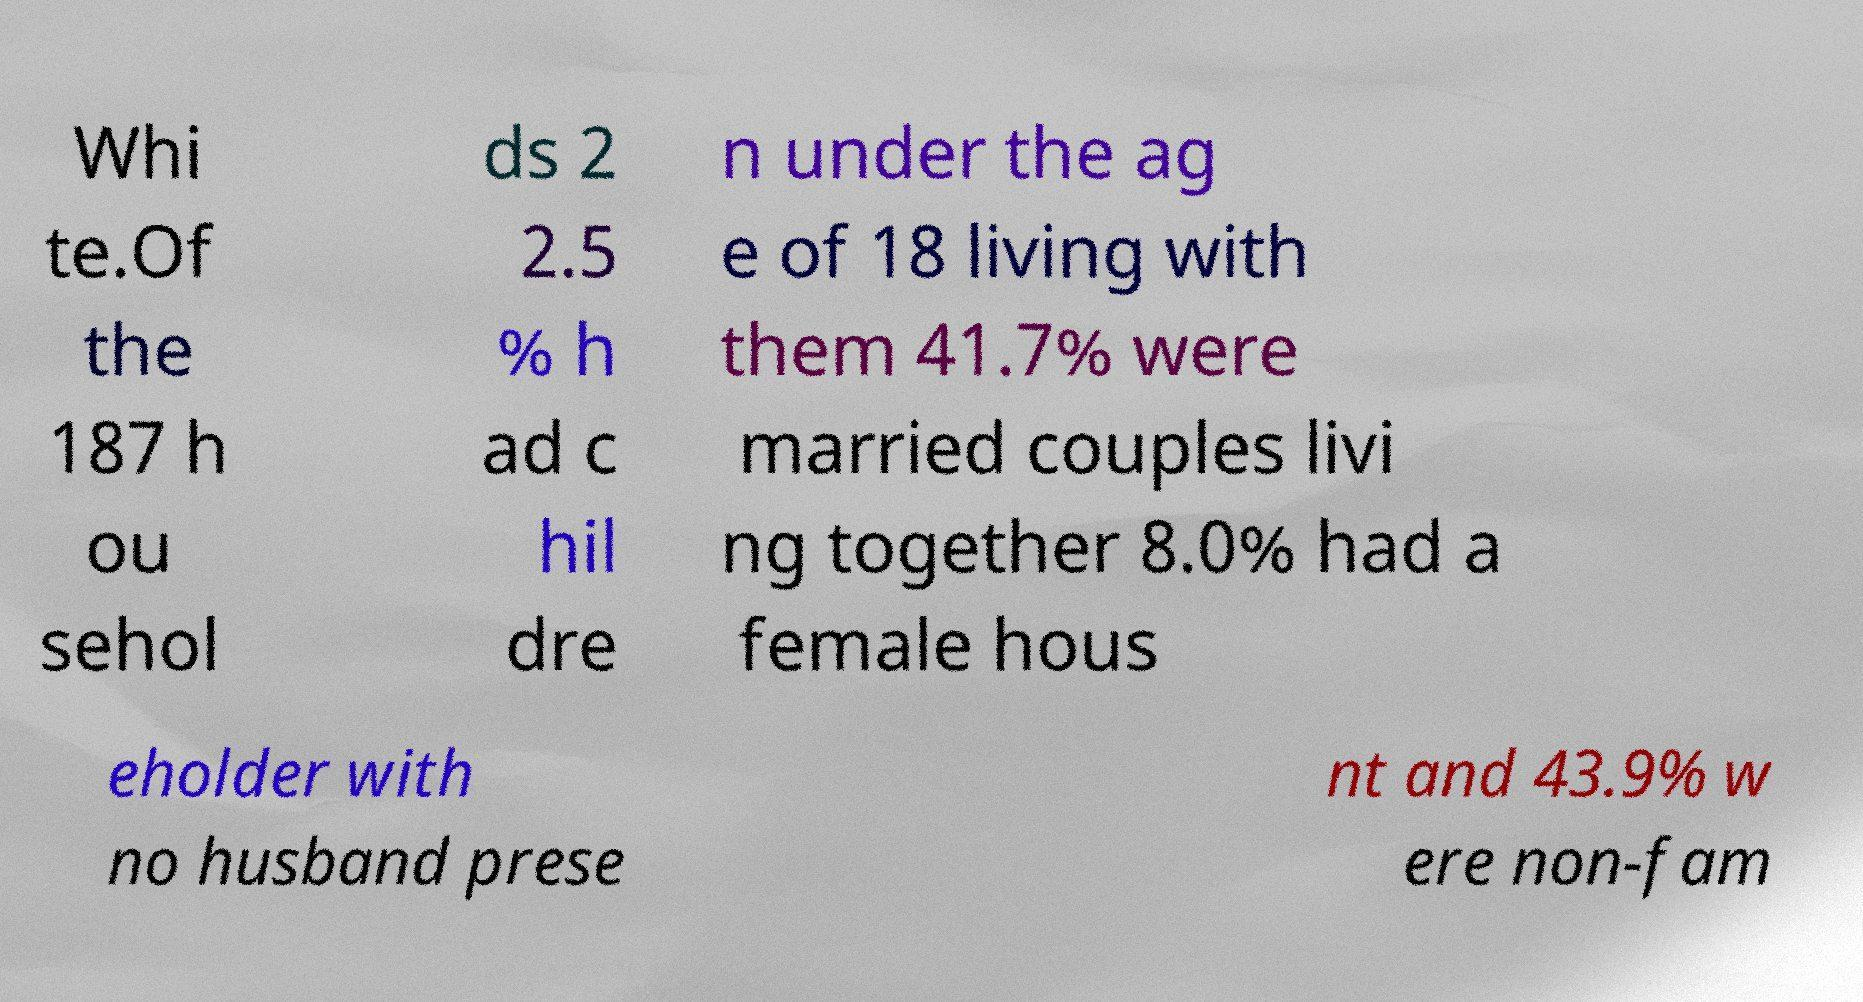What messages or text are displayed in this image? I need them in a readable, typed format. Whi te.Of the 187 h ou sehol ds 2 2.5 % h ad c hil dre n under the ag e of 18 living with them 41.7% were married couples livi ng together 8.0% had a female hous eholder with no husband prese nt and 43.9% w ere non-fam 